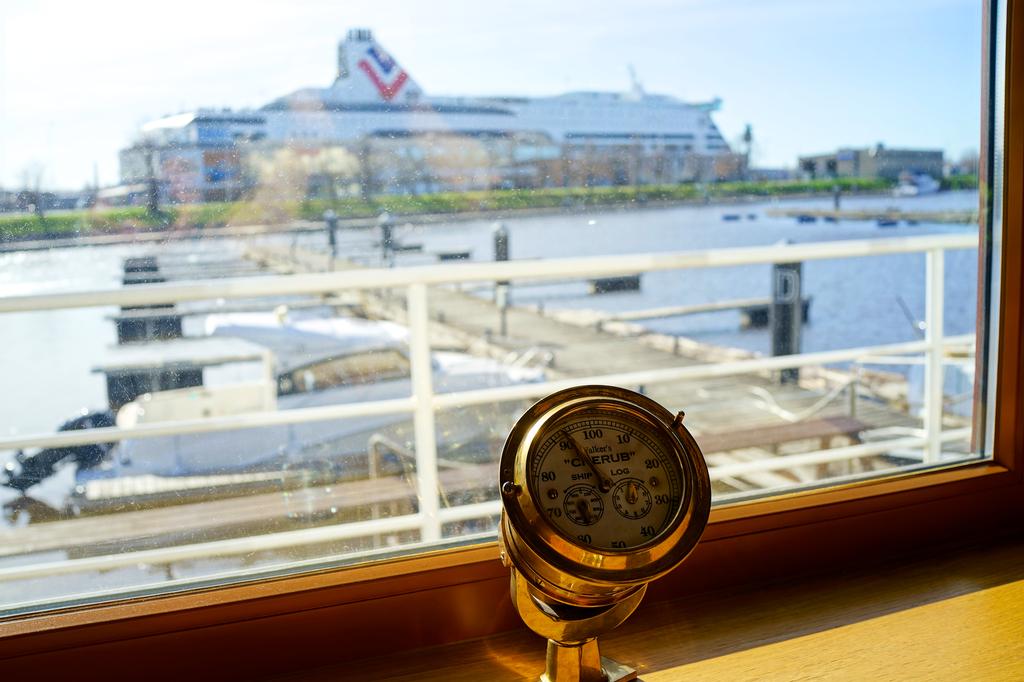Who is the creator of this thermometer?
Your answer should be very brief. Cherub. 